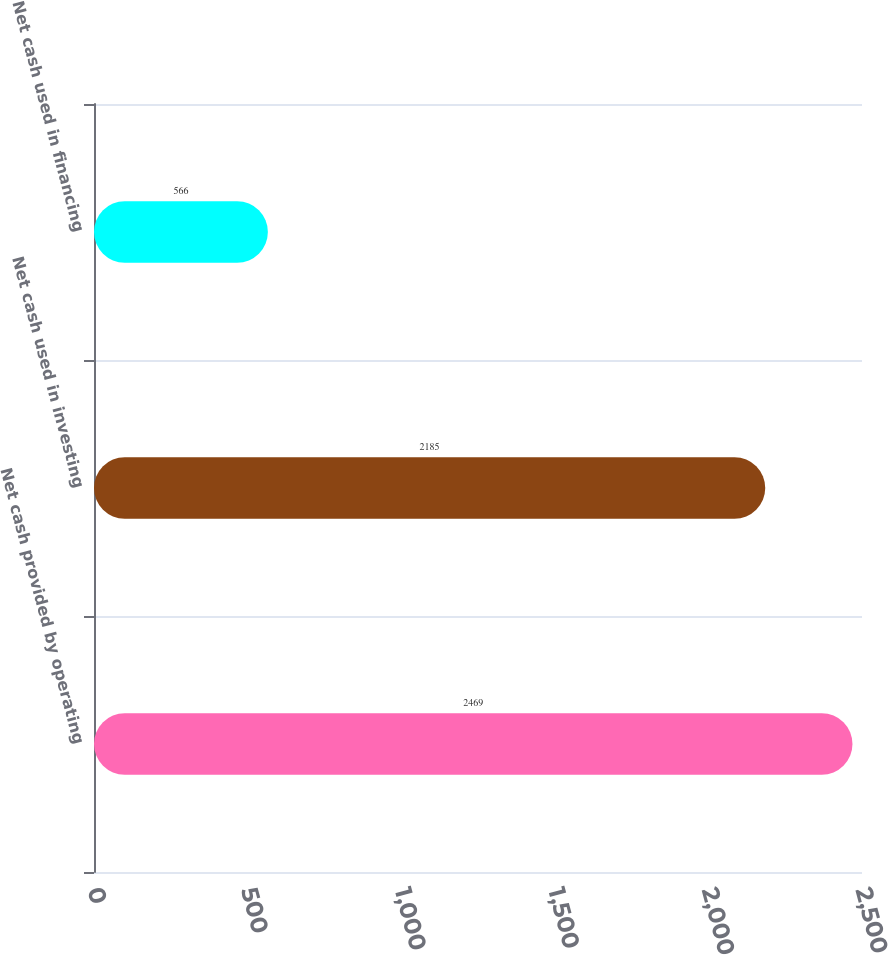Convert chart to OTSL. <chart><loc_0><loc_0><loc_500><loc_500><bar_chart><fcel>Net cash provided by operating<fcel>Net cash used in investing<fcel>Net cash used in financing<nl><fcel>2469<fcel>2185<fcel>566<nl></chart> 